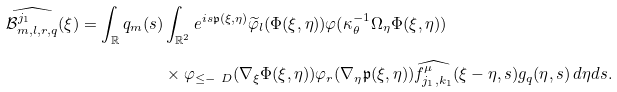<formula> <loc_0><loc_0><loc_500><loc_500>\widehat { \mathcal { B } _ { m , l , r , q } ^ { j _ { 1 } } } ( \xi ) = \int _ { \mathbb { R } } q _ { m } ( s ) & \int _ { \mathbb { R } ^ { 2 } } e ^ { i s \mathfrak { p } ( \xi , \eta ) } \widetilde { \varphi } _ { l } ( \Phi ( \xi , \eta ) ) \varphi ( \kappa _ { \theta } ^ { - 1 } \Omega _ { \eta } \Phi ( \xi , \eta ) ) \\ & \times \varphi _ { \leq - \ D } ( \nabla _ { \xi } \Phi ( \xi , \eta ) ) \varphi _ { r } ( \nabla _ { \eta } \mathfrak { p } ( \xi , \eta ) ) \widehat { f ^ { \mu } _ { j _ { 1 } , k _ { 1 } } } ( \xi - \eta , s ) g _ { q } ( \eta , s ) \, d \eta d s . \\</formula> 